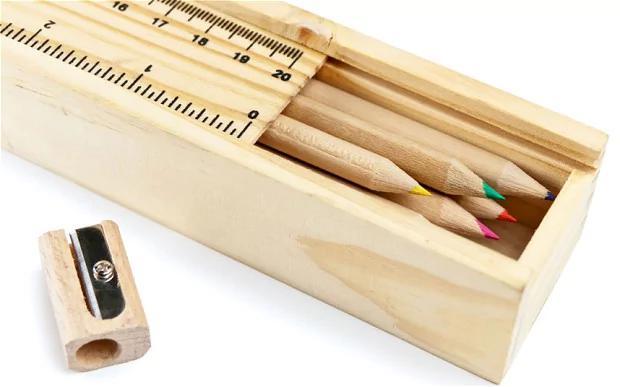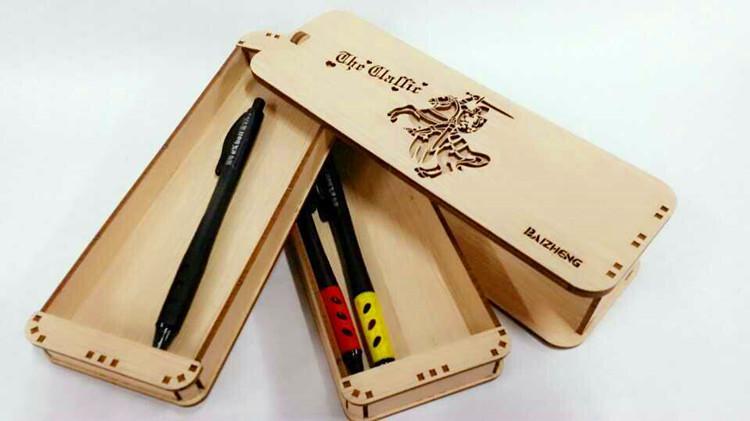The first image is the image on the left, the second image is the image on the right. Analyze the images presented: Is the assertion "There is at least one open wooden pencil case." valid? Answer yes or no. Yes. The first image is the image on the left, the second image is the image on the right. Considering the images on both sides, is "the case in the image on the left is open" valid? Answer yes or no. Yes. 